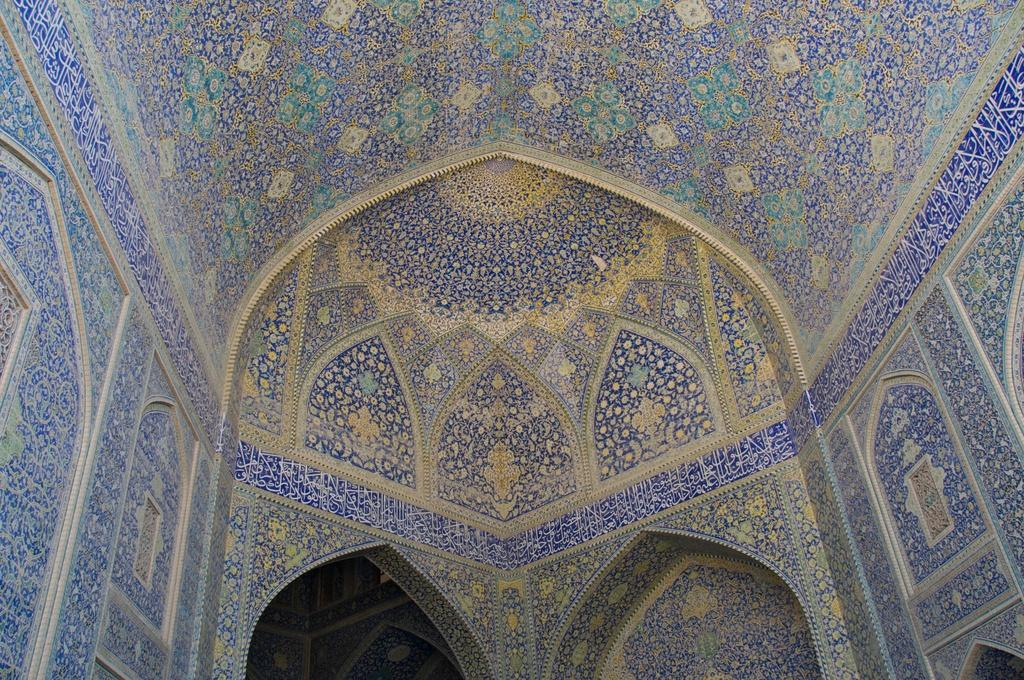What is the main subject of the image? The main subject of the image is a building. Can you describe the building's structure? The building has a wall and a roof. What can be seen on the wall of the building? There is artwork on the wall of the building. How does the fan help with the building's digestion in the image? There is no fan present in the image, and buildings do not have digestive systems. 